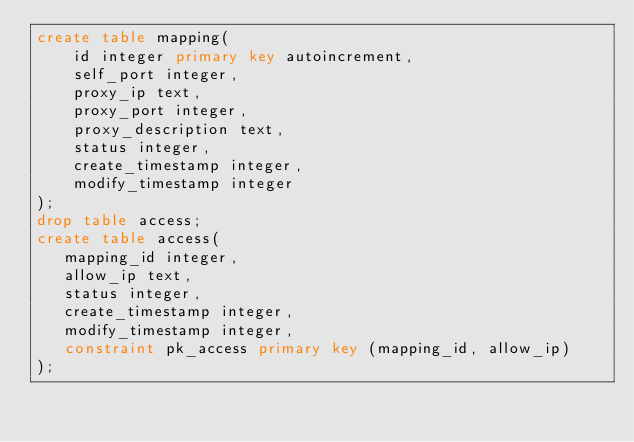Convert code to text. <code><loc_0><loc_0><loc_500><loc_500><_SQL_>create table mapping(
    id integer primary key autoincrement,
    self_port integer,
    proxy_ip text,
    proxy_port integer,
    proxy_description text,
    status integer,
    create_timestamp integer,
    modify_timestamp integer
);
drop table access;
create table access(
   mapping_id integer,
   allow_ip text,
   status integer,
   create_timestamp integer,
   modify_timestamp integer,
   constraint pk_access primary key (mapping_id, allow_ip)
);</code> 